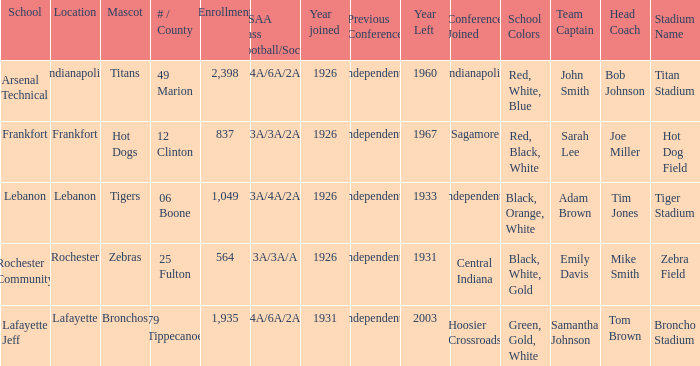What is the average enrollment that has hot dogs as the mascot, with a year joined later than 1926? None. 